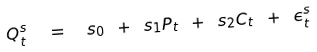<formula> <loc_0><loc_0><loc_500><loc_500>Q ^ { s } _ { t } \ \ = \ \ s _ { 0 } \ + \ s _ { 1 } P _ { t } \ + \ s _ { 2 } C _ { t } \ + \ \epsilon ^ { s } _ { t }</formula> 